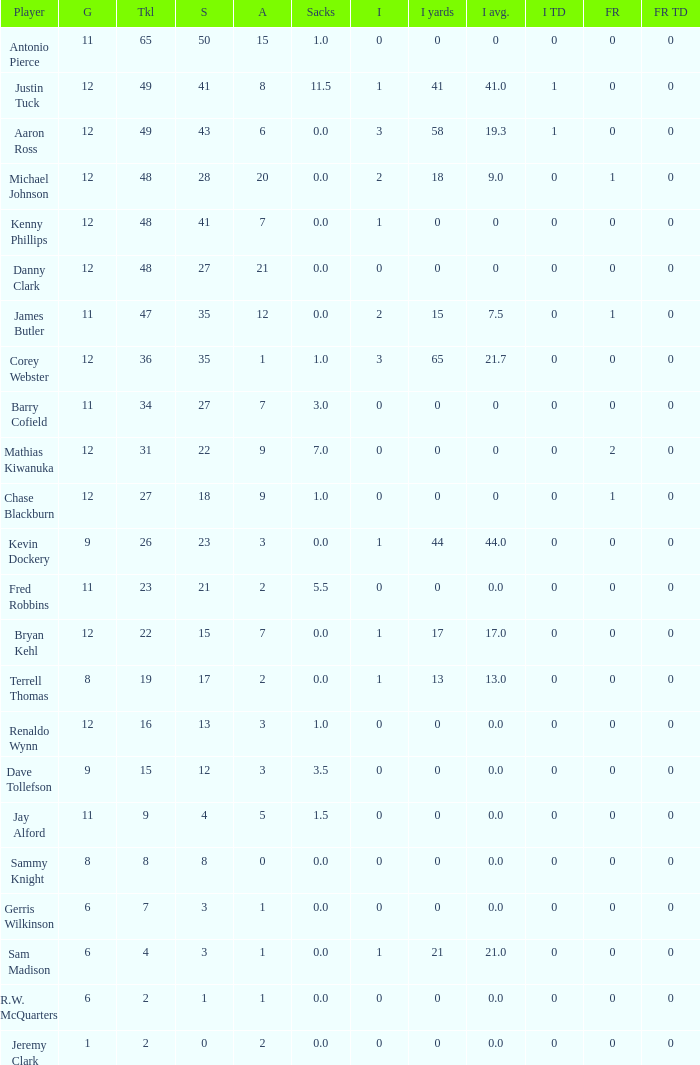Name the least amount of tackles for danny clark 48.0. 